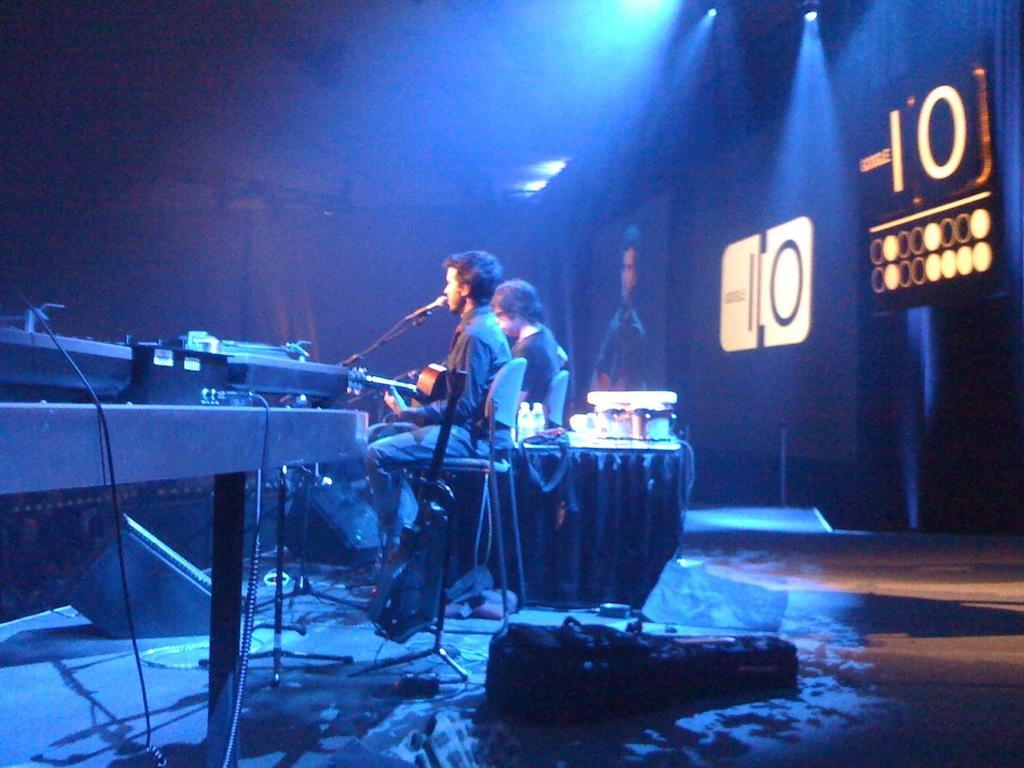How many people are in the image? There are two men in the image. What are the men doing in the image? The men are seated on chairs, and one of them is speaking with the help of a microphone. What object can be seen on the table in the image? The provided facts do not mention any specific object on the table. What is the opinion of the straw about the comparison between the two men in the image? There is no straw present in the image, and therefore no such opinion can be attributed to it. 